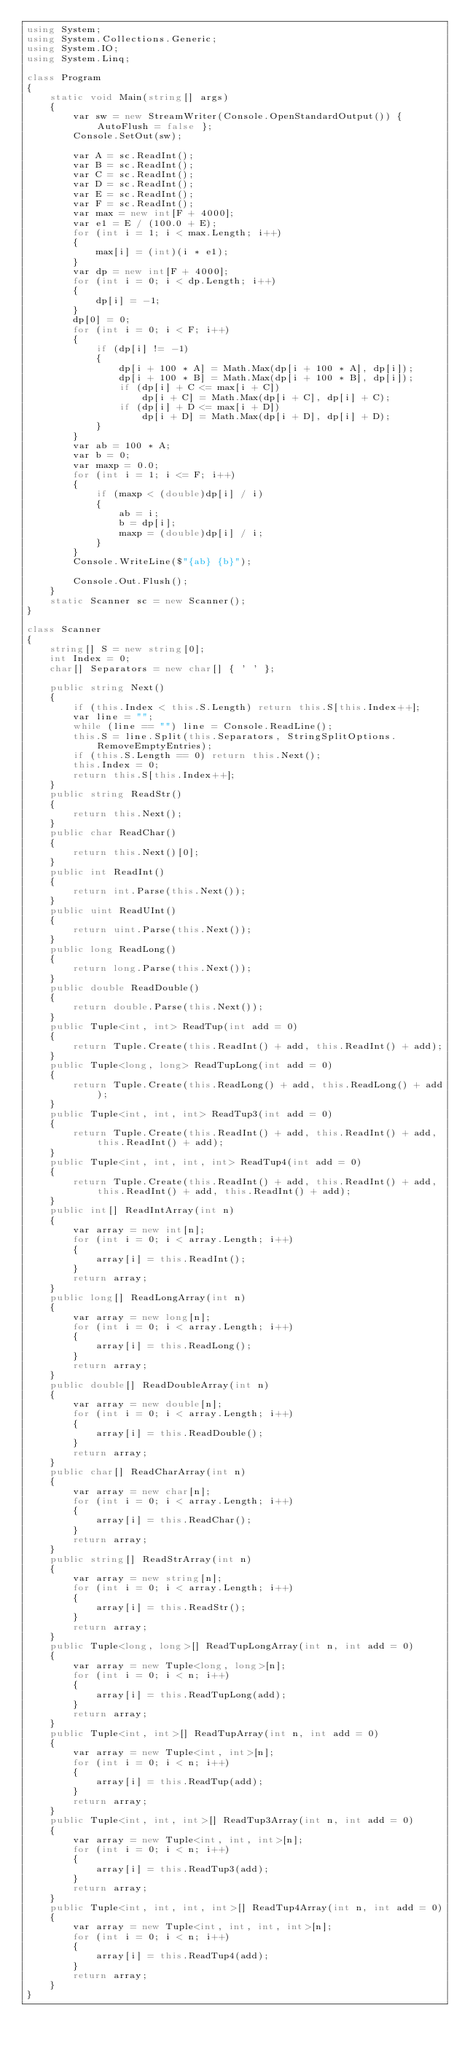<code> <loc_0><loc_0><loc_500><loc_500><_C#_>using System;
using System.Collections.Generic;
using System.IO;
using System.Linq;

class Program
{
    static void Main(string[] args)
    {
        var sw = new StreamWriter(Console.OpenStandardOutput()) { AutoFlush = false };
        Console.SetOut(sw);

        var A = sc.ReadInt();
        var B = sc.ReadInt();
        var C = sc.ReadInt();
        var D = sc.ReadInt();
        var E = sc.ReadInt();
        var F = sc.ReadInt();
        var max = new int[F + 4000];
        var e1 = E / (100.0 + E);
        for (int i = 1; i < max.Length; i++)
        {
            max[i] = (int)(i * e1);
        }
        var dp = new int[F + 4000];
        for (int i = 0; i < dp.Length; i++)
        {
            dp[i] = -1;
        }
        dp[0] = 0;
        for (int i = 0; i < F; i++)
        {
            if (dp[i] != -1)
            {
                dp[i + 100 * A] = Math.Max(dp[i + 100 * A], dp[i]);
                dp[i + 100 * B] = Math.Max(dp[i + 100 * B], dp[i]);
                if (dp[i] + C <= max[i + C])
                    dp[i + C] = Math.Max(dp[i + C], dp[i] + C);
                if (dp[i] + D <= max[i + D])
                    dp[i + D] = Math.Max(dp[i + D], dp[i] + D);
            }
        }
        var ab = 100 * A;
        var b = 0;
        var maxp = 0.0;
        for (int i = 1; i <= F; i++)
        {
            if (maxp < (double)dp[i] / i)
            {
                ab = i;
                b = dp[i];
                maxp = (double)dp[i] / i;
            }
        }
        Console.WriteLine($"{ab} {b}");

        Console.Out.Flush();
    }
    static Scanner sc = new Scanner();
}

class Scanner
{
    string[] S = new string[0];
    int Index = 0;
    char[] Separators = new char[] { ' ' };

    public string Next()
    {
        if (this.Index < this.S.Length) return this.S[this.Index++];
        var line = "";
        while (line == "") line = Console.ReadLine();
        this.S = line.Split(this.Separators, StringSplitOptions.RemoveEmptyEntries);
        if (this.S.Length == 0) return this.Next();
        this.Index = 0;
        return this.S[this.Index++];
    }
    public string ReadStr()
    {
        return this.Next();
    }
    public char ReadChar()
    {
        return this.Next()[0];
    }
    public int ReadInt()
    {
        return int.Parse(this.Next());
    }
    public uint ReadUInt()
    {
        return uint.Parse(this.Next());
    }
    public long ReadLong()
    {
        return long.Parse(this.Next());
    }
    public double ReadDouble()
    {
        return double.Parse(this.Next());
    }
    public Tuple<int, int> ReadTup(int add = 0)
    {
        return Tuple.Create(this.ReadInt() + add, this.ReadInt() + add);
    }
    public Tuple<long, long> ReadTupLong(int add = 0)
    {
        return Tuple.Create(this.ReadLong() + add, this.ReadLong() + add);
    }
    public Tuple<int, int, int> ReadTup3(int add = 0)
    {
        return Tuple.Create(this.ReadInt() + add, this.ReadInt() + add, this.ReadInt() + add);
    }
    public Tuple<int, int, int, int> ReadTup4(int add = 0)
    {
        return Tuple.Create(this.ReadInt() + add, this.ReadInt() + add, this.ReadInt() + add, this.ReadInt() + add);
    }
    public int[] ReadIntArray(int n)
    {
        var array = new int[n];
        for (int i = 0; i < array.Length; i++)
        {
            array[i] = this.ReadInt();
        }
        return array;
    }
    public long[] ReadLongArray(int n)
    {
        var array = new long[n];
        for (int i = 0; i < array.Length; i++)
        {
            array[i] = this.ReadLong();
        }
        return array;
    }
    public double[] ReadDoubleArray(int n)
    {
        var array = new double[n];
        for (int i = 0; i < array.Length; i++)
        {
            array[i] = this.ReadDouble();
        }
        return array;
    }
    public char[] ReadCharArray(int n)
    {
        var array = new char[n];
        for (int i = 0; i < array.Length; i++)
        {
            array[i] = this.ReadChar();
        }
        return array;
    }
    public string[] ReadStrArray(int n)
    {
        var array = new string[n];
        for (int i = 0; i < array.Length; i++)
        {
            array[i] = this.ReadStr();
        }
        return array;
    }
    public Tuple<long, long>[] ReadTupLongArray(int n, int add = 0)
    {
        var array = new Tuple<long, long>[n];
        for (int i = 0; i < n; i++)
        {
            array[i] = this.ReadTupLong(add);
        }
        return array;
    }
    public Tuple<int, int>[] ReadTupArray(int n, int add = 0)
    {
        var array = new Tuple<int, int>[n];
        for (int i = 0; i < n; i++)
        {
            array[i] = this.ReadTup(add);
        }
        return array;
    }
    public Tuple<int, int, int>[] ReadTup3Array(int n, int add = 0)
    {
        var array = new Tuple<int, int, int>[n];
        for (int i = 0; i < n; i++)
        {
            array[i] = this.ReadTup3(add);
        }
        return array;
    }
    public Tuple<int, int, int, int>[] ReadTup4Array(int n, int add = 0)
    {
        var array = new Tuple<int, int, int, int>[n];
        for (int i = 0; i < n; i++)
        {
            array[i] = this.ReadTup4(add);
        }
        return array;
    }
}
</code> 